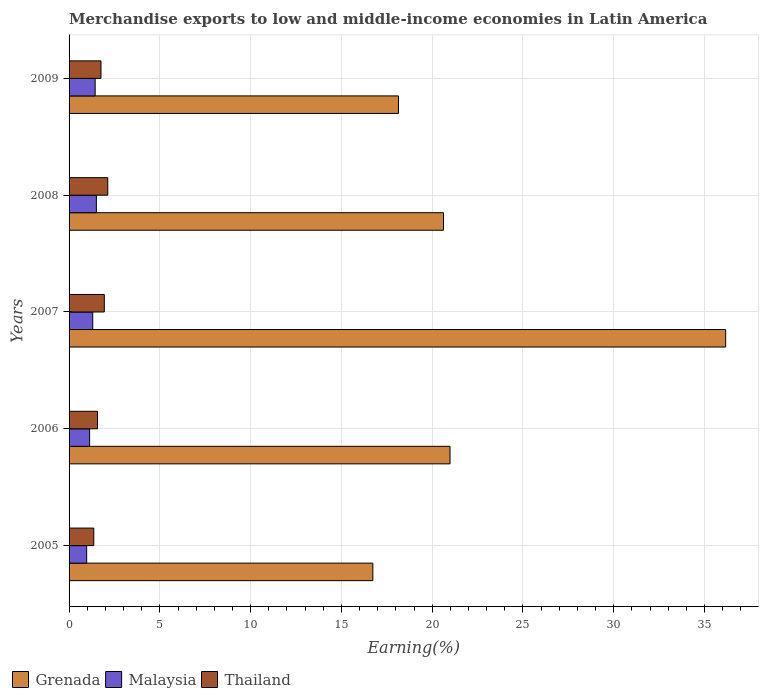How many different coloured bars are there?
Provide a short and direct response. 3. Are the number of bars per tick equal to the number of legend labels?
Provide a short and direct response. Yes. Are the number of bars on each tick of the Y-axis equal?
Offer a terse response. Yes. How many bars are there on the 5th tick from the top?
Give a very brief answer. 3. What is the label of the 4th group of bars from the top?
Give a very brief answer. 2006. In how many cases, is the number of bars for a given year not equal to the number of legend labels?
Make the answer very short. 0. What is the percentage of amount earned from merchandise exports in Thailand in 2009?
Keep it short and to the point. 1.76. Across all years, what is the maximum percentage of amount earned from merchandise exports in Grenada?
Offer a terse response. 36.16. Across all years, what is the minimum percentage of amount earned from merchandise exports in Thailand?
Keep it short and to the point. 1.36. What is the total percentage of amount earned from merchandise exports in Grenada in the graph?
Ensure brevity in your answer.  112.64. What is the difference between the percentage of amount earned from merchandise exports in Grenada in 2006 and that in 2007?
Your answer should be very brief. -15.18. What is the difference between the percentage of amount earned from merchandise exports in Thailand in 2005 and the percentage of amount earned from merchandise exports in Grenada in 2009?
Your answer should be compact. -16.78. What is the average percentage of amount earned from merchandise exports in Thailand per year?
Keep it short and to the point. 1.75. In the year 2006, what is the difference between the percentage of amount earned from merchandise exports in Malaysia and percentage of amount earned from merchandise exports in Grenada?
Provide a succinct answer. -19.85. What is the ratio of the percentage of amount earned from merchandise exports in Malaysia in 2006 to that in 2009?
Provide a short and direct response. 0.79. Is the percentage of amount earned from merchandise exports in Thailand in 2007 less than that in 2009?
Make the answer very short. No. Is the difference between the percentage of amount earned from merchandise exports in Malaysia in 2005 and 2008 greater than the difference between the percentage of amount earned from merchandise exports in Grenada in 2005 and 2008?
Offer a very short reply. Yes. What is the difference between the highest and the second highest percentage of amount earned from merchandise exports in Grenada?
Provide a short and direct response. 15.18. What is the difference between the highest and the lowest percentage of amount earned from merchandise exports in Malaysia?
Provide a succinct answer. 0.53. In how many years, is the percentage of amount earned from merchandise exports in Malaysia greater than the average percentage of amount earned from merchandise exports in Malaysia taken over all years?
Provide a short and direct response. 3. What does the 2nd bar from the top in 2009 represents?
Make the answer very short. Malaysia. What does the 1st bar from the bottom in 2008 represents?
Offer a very short reply. Grenada. Are all the bars in the graph horizontal?
Keep it short and to the point. Yes. Are the values on the major ticks of X-axis written in scientific E-notation?
Offer a terse response. No. Does the graph contain any zero values?
Ensure brevity in your answer.  No. How are the legend labels stacked?
Keep it short and to the point. Horizontal. What is the title of the graph?
Your answer should be very brief. Merchandise exports to low and middle-income economies in Latin America. Does "Kenya" appear as one of the legend labels in the graph?
Offer a very short reply. No. What is the label or title of the X-axis?
Provide a succinct answer. Earning(%). What is the label or title of the Y-axis?
Keep it short and to the point. Years. What is the Earning(%) of Grenada in 2005?
Make the answer very short. 16.73. What is the Earning(%) in Malaysia in 2005?
Your answer should be very brief. 0.97. What is the Earning(%) in Thailand in 2005?
Offer a terse response. 1.36. What is the Earning(%) of Grenada in 2006?
Your answer should be very brief. 20.98. What is the Earning(%) of Malaysia in 2006?
Ensure brevity in your answer.  1.13. What is the Earning(%) of Thailand in 2006?
Keep it short and to the point. 1.57. What is the Earning(%) of Grenada in 2007?
Give a very brief answer. 36.16. What is the Earning(%) in Malaysia in 2007?
Keep it short and to the point. 1.3. What is the Earning(%) in Thailand in 2007?
Ensure brevity in your answer.  1.94. What is the Earning(%) in Grenada in 2008?
Make the answer very short. 20.62. What is the Earning(%) in Malaysia in 2008?
Your answer should be compact. 1.5. What is the Earning(%) of Thailand in 2008?
Your response must be concise. 2.13. What is the Earning(%) of Grenada in 2009?
Your answer should be very brief. 18.14. What is the Earning(%) in Malaysia in 2009?
Give a very brief answer. 1.44. What is the Earning(%) of Thailand in 2009?
Provide a succinct answer. 1.76. Across all years, what is the maximum Earning(%) in Grenada?
Provide a succinct answer. 36.16. Across all years, what is the maximum Earning(%) of Malaysia?
Offer a very short reply. 1.5. Across all years, what is the maximum Earning(%) of Thailand?
Provide a short and direct response. 2.13. Across all years, what is the minimum Earning(%) in Grenada?
Make the answer very short. 16.73. Across all years, what is the minimum Earning(%) in Malaysia?
Make the answer very short. 0.97. Across all years, what is the minimum Earning(%) of Thailand?
Ensure brevity in your answer.  1.36. What is the total Earning(%) in Grenada in the graph?
Offer a terse response. 112.64. What is the total Earning(%) of Malaysia in the graph?
Your answer should be compact. 6.34. What is the total Earning(%) in Thailand in the graph?
Keep it short and to the point. 8.76. What is the difference between the Earning(%) of Grenada in 2005 and that in 2006?
Your answer should be compact. -4.25. What is the difference between the Earning(%) in Malaysia in 2005 and that in 2006?
Ensure brevity in your answer.  -0.16. What is the difference between the Earning(%) of Thailand in 2005 and that in 2006?
Offer a very short reply. -0.2. What is the difference between the Earning(%) in Grenada in 2005 and that in 2007?
Your answer should be compact. -19.43. What is the difference between the Earning(%) in Malaysia in 2005 and that in 2007?
Your answer should be compact. -0.33. What is the difference between the Earning(%) in Thailand in 2005 and that in 2007?
Make the answer very short. -0.58. What is the difference between the Earning(%) in Grenada in 2005 and that in 2008?
Provide a succinct answer. -3.89. What is the difference between the Earning(%) in Malaysia in 2005 and that in 2008?
Give a very brief answer. -0.53. What is the difference between the Earning(%) of Thailand in 2005 and that in 2008?
Ensure brevity in your answer.  -0.77. What is the difference between the Earning(%) in Grenada in 2005 and that in 2009?
Your response must be concise. -1.41. What is the difference between the Earning(%) in Malaysia in 2005 and that in 2009?
Your answer should be compact. -0.47. What is the difference between the Earning(%) in Thailand in 2005 and that in 2009?
Provide a short and direct response. -0.4. What is the difference between the Earning(%) in Grenada in 2006 and that in 2007?
Give a very brief answer. -15.18. What is the difference between the Earning(%) of Malaysia in 2006 and that in 2007?
Provide a succinct answer. -0.17. What is the difference between the Earning(%) of Thailand in 2006 and that in 2007?
Your response must be concise. -0.37. What is the difference between the Earning(%) in Grenada in 2006 and that in 2008?
Your answer should be compact. 0.36. What is the difference between the Earning(%) of Malaysia in 2006 and that in 2008?
Your response must be concise. -0.37. What is the difference between the Earning(%) in Thailand in 2006 and that in 2008?
Provide a short and direct response. -0.56. What is the difference between the Earning(%) in Grenada in 2006 and that in 2009?
Your answer should be compact. 2.84. What is the difference between the Earning(%) in Malaysia in 2006 and that in 2009?
Offer a terse response. -0.31. What is the difference between the Earning(%) of Thailand in 2006 and that in 2009?
Make the answer very short. -0.19. What is the difference between the Earning(%) of Grenada in 2007 and that in 2008?
Provide a succinct answer. 15.54. What is the difference between the Earning(%) in Malaysia in 2007 and that in 2008?
Offer a terse response. -0.2. What is the difference between the Earning(%) in Thailand in 2007 and that in 2008?
Your answer should be compact. -0.19. What is the difference between the Earning(%) in Grenada in 2007 and that in 2009?
Keep it short and to the point. 18.02. What is the difference between the Earning(%) in Malaysia in 2007 and that in 2009?
Make the answer very short. -0.13. What is the difference between the Earning(%) of Thailand in 2007 and that in 2009?
Make the answer very short. 0.18. What is the difference between the Earning(%) in Grenada in 2008 and that in 2009?
Make the answer very short. 2.48. What is the difference between the Earning(%) in Malaysia in 2008 and that in 2009?
Ensure brevity in your answer.  0.07. What is the difference between the Earning(%) of Thailand in 2008 and that in 2009?
Ensure brevity in your answer.  0.37. What is the difference between the Earning(%) in Grenada in 2005 and the Earning(%) in Malaysia in 2006?
Offer a very short reply. 15.6. What is the difference between the Earning(%) in Grenada in 2005 and the Earning(%) in Thailand in 2006?
Provide a succinct answer. 15.17. What is the difference between the Earning(%) of Malaysia in 2005 and the Earning(%) of Thailand in 2006?
Ensure brevity in your answer.  -0.6. What is the difference between the Earning(%) of Grenada in 2005 and the Earning(%) of Malaysia in 2007?
Provide a succinct answer. 15.43. What is the difference between the Earning(%) of Grenada in 2005 and the Earning(%) of Thailand in 2007?
Your response must be concise. 14.79. What is the difference between the Earning(%) in Malaysia in 2005 and the Earning(%) in Thailand in 2007?
Keep it short and to the point. -0.97. What is the difference between the Earning(%) of Grenada in 2005 and the Earning(%) of Malaysia in 2008?
Your response must be concise. 15.23. What is the difference between the Earning(%) of Grenada in 2005 and the Earning(%) of Thailand in 2008?
Offer a very short reply. 14.6. What is the difference between the Earning(%) in Malaysia in 2005 and the Earning(%) in Thailand in 2008?
Ensure brevity in your answer.  -1.16. What is the difference between the Earning(%) of Grenada in 2005 and the Earning(%) of Malaysia in 2009?
Make the answer very short. 15.29. What is the difference between the Earning(%) in Grenada in 2005 and the Earning(%) in Thailand in 2009?
Your answer should be very brief. 14.97. What is the difference between the Earning(%) of Malaysia in 2005 and the Earning(%) of Thailand in 2009?
Your answer should be compact. -0.79. What is the difference between the Earning(%) of Grenada in 2006 and the Earning(%) of Malaysia in 2007?
Give a very brief answer. 19.68. What is the difference between the Earning(%) of Grenada in 2006 and the Earning(%) of Thailand in 2007?
Make the answer very short. 19.04. What is the difference between the Earning(%) of Malaysia in 2006 and the Earning(%) of Thailand in 2007?
Your answer should be compact. -0.81. What is the difference between the Earning(%) of Grenada in 2006 and the Earning(%) of Malaysia in 2008?
Give a very brief answer. 19.48. What is the difference between the Earning(%) of Grenada in 2006 and the Earning(%) of Thailand in 2008?
Ensure brevity in your answer.  18.85. What is the difference between the Earning(%) of Malaysia in 2006 and the Earning(%) of Thailand in 2008?
Give a very brief answer. -1. What is the difference between the Earning(%) of Grenada in 2006 and the Earning(%) of Malaysia in 2009?
Offer a very short reply. 19.55. What is the difference between the Earning(%) of Grenada in 2006 and the Earning(%) of Thailand in 2009?
Ensure brevity in your answer.  19.22. What is the difference between the Earning(%) of Malaysia in 2006 and the Earning(%) of Thailand in 2009?
Offer a very short reply. -0.63. What is the difference between the Earning(%) in Grenada in 2007 and the Earning(%) in Malaysia in 2008?
Offer a terse response. 34.66. What is the difference between the Earning(%) in Grenada in 2007 and the Earning(%) in Thailand in 2008?
Your answer should be very brief. 34.03. What is the difference between the Earning(%) of Malaysia in 2007 and the Earning(%) of Thailand in 2008?
Your answer should be compact. -0.83. What is the difference between the Earning(%) in Grenada in 2007 and the Earning(%) in Malaysia in 2009?
Offer a very short reply. 34.73. What is the difference between the Earning(%) in Grenada in 2007 and the Earning(%) in Thailand in 2009?
Keep it short and to the point. 34.41. What is the difference between the Earning(%) in Malaysia in 2007 and the Earning(%) in Thailand in 2009?
Your answer should be compact. -0.45. What is the difference between the Earning(%) in Grenada in 2008 and the Earning(%) in Malaysia in 2009?
Provide a short and direct response. 19.19. What is the difference between the Earning(%) in Grenada in 2008 and the Earning(%) in Thailand in 2009?
Make the answer very short. 18.86. What is the difference between the Earning(%) of Malaysia in 2008 and the Earning(%) of Thailand in 2009?
Offer a terse response. -0.25. What is the average Earning(%) in Grenada per year?
Your answer should be very brief. 22.53. What is the average Earning(%) in Malaysia per year?
Your answer should be very brief. 1.27. What is the average Earning(%) in Thailand per year?
Keep it short and to the point. 1.75. In the year 2005, what is the difference between the Earning(%) in Grenada and Earning(%) in Malaysia?
Keep it short and to the point. 15.76. In the year 2005, what is the difference between the Earning(%) of Grenada and Earning(%) of Thailand?
Your answer should be compact. 15.37. In the year 2005, what is the difference between the Earning(%) of Malaysia and Earning(%) of Thailand?
Your response must be concise. -0.39. In the year 2006, what is the difference between the Earning(%) in Grenada and Earning(%) in Malaysia?
Provide a succinct answer. 19.85. In the year 2006, what is the difference between the Earning(%) in Grenada and Earning(%) in Thailand?
Provide a short and direct response. 19.42. In the year 2006, what is the difference between the Earning(%) in Malaysia and Earning(%) in Thailand?
Your answer should be compact. -0.43. In the year 2007, what is the difference between the Earning(%) of Grenada and Earning(%) of Malaysia?
Your answer should be very brief. 34.86. In the year 2007, what is the difference between the Earning(%) in Grenada and Earning(%) in Thailand?
Give a very brief answer. 34.22. In the year 2007, what is the difference between the Earning(%) of Malaysia and Earning(%) of Thailand?
Your answer should be very brief. -0.64. In the year 2008, what is the difference between the Earning(%) of Grenada and Earning(%) of Malaysia?
Provide a succinct answer. 19.12. In the year 2008, what is the difference between the Earning(%) of Grenada and Earning(%) of Thailand?
Your answer should be compact. 18.49. In the year 2008, what is the difference between the Earning(%) in Malaysia and Earning(%) in Thailand?
Provide a succinct answer. -0.63. In the year 2009, what is the difference between the Earning(%) in Grenada and Earning(%) in Malaysia?
Your response must be concise. 16.71. In the year 2009, what is the difference between the Earning(%) in Grenada and Earning(%) in Thailand?
Your answer should be very brief. 16.38. In the year 2009, what is the difference between the Earning(%) of Malaysia and Earning(%) of Thailand?
Provide a succinct answer. -0.32. What is the ratio of the Earning(%) in Grenada in 2005 to that in 2006?
Make the answer very short. 0.8. What is the ratio of the Earning(%) of Malaysia in 2005 to that in 2006?
Make the answer very short. 0.86. What is the ratio of the Earning(%) of Thailand in 2005 to that in 2006?
Offer a very short reply. 0.87. What is the ratio of the Earning(%) of Grenada in 2005 to that in 2007?
Give a very brief answer. 0.46. What is the ratio of the Earning(%) of Malaysia in 2005 to that in 2007?
Keep it short and to the point. 0.74. What is the ratio of the Earning(%) of Thailand in 2005 to that in 2007?
Provide a short and direct response. 0.7. What is the ratio of the Earning(%) in Grenada in 2005 to that in 2008?
Your response must be concise. 0.81. What is the ratio of the Earning(%) of Malaysia in 2005 to that in 2008?
Ensure brevity in your answer.  0.64. What is the ratio of the Earning(%) in Thailand in 2005 to that in 2008?
Offer a terse response. 0.64. What is the ratio of the Earning(%) in Grenada in 2005 to that in 2009?
Provide a succinct answer. 0.92. What is the ratio of the Earning(%) of Malaysia in 2005 to that in 2009?
Give a very brief answer. 0.67. What is the ratio of the Earning(%) of Thailand in 2005 to that in 2009?
Your answer should be very brief. 0.77. What is the ratio of the Earning(%) of Grenada in 2006 to that in 2007?
Your answer should be very brief. 0.58. What is the ratio of the Earning(%) in Malaysia in 2006 to that in 2007?
Your response must be concise. 0.87. What is the ratio of the Earning(%) in Thailand in 2006 to that in 2007?
Make the answer very short. 0.81. What is the ratio of the Earning(%) in Grenada in 2006 to that in 2008?
Offer a very short reply. 1.02. What is the ratio of the Earning(%) in Malaysia in 2006 to that in 2008?
Your response must be concise. 0.75. What is the ratio of the Earning(%) in Thailand in 2006 to that in 2008?
Offer a very short reply. 0.74. What is the ratio of the Earning(%) in Grenada in 2006 to that in 2009?
Offer a very short reply. 1.16. What is the ratio of the Earning(%) of Malaysia in 2006 to that in 2009?
Make the answer very short. 0.79. What is the ratio of the Earning(%) in Thailand in 2006 to that in 2009?
Your response must be concise. 0.89. What is the ratio of the Earning(%) in Grenada in 2007 to that in 2008?
Offer a terse response. 1.75. What is the ratio of the Earning(%) of Malaysia in 2007 to that in 2008?
Your response must be concise. 0.87. What is the ratio of the Earning(%) of Thailand in 2007 to that in 2008?
Your answer should be compact. 0.91. What is the ratio of the Earning(%) in Grenada in 2007 to that in 2009?
Offer a very short reply. 1.99. What is the ratio of the Earning(%) in Malaysia in 2007 to that in 2009?
Ensure brevity in your answer.  0.91. What is the ratio of the Earning(%) of Thailand in 2007 to that in 2009?
Your response must be concise. 1.1. What is the ratio of the Earning(%) of Grenada in 2008 to that in 2009?
Your answer should be compact. 1.14. What is the ratio of the Earning(%) in Malaysia in 2008 to that in 2009?
Your answer should be compact. 1.05. What is the ratio of the Earning(%) in Thailand in 2008 to that in 2009?
Your response must be concise. 1.21. What is the difference between the highest and the second highest Earning(%) in Grenada?
Your answer should be compact. 15.18. What is the difference between the highest and the second highest Earning(%) of Malaysia?
Ensure brevity in your answer.  0.07. What is the difference between the highest and the second highest Earning(%) of Thailand?
Provide a succinct answer. 0.19. What is the difference between the highest and the lowest Earning(%) in Grenada?
Ensure brevity in your answer.  19.43. What is the difference between the highest and the lowest Earning(%) of Malaysia?
Your answer should be very brief. 0.53. What is the difference between the highest and the lowest Earning(%) in Thailand?
Your answer should be very brief. 0.77. 